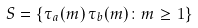Convert formula to latex. <formula><loc_0><loc_0><loc_500><loc_500>S = \{ \tau _ { a } ( m ) \, \tau _ { b } ( m ) \colon m \geq 1 \}</formula> 